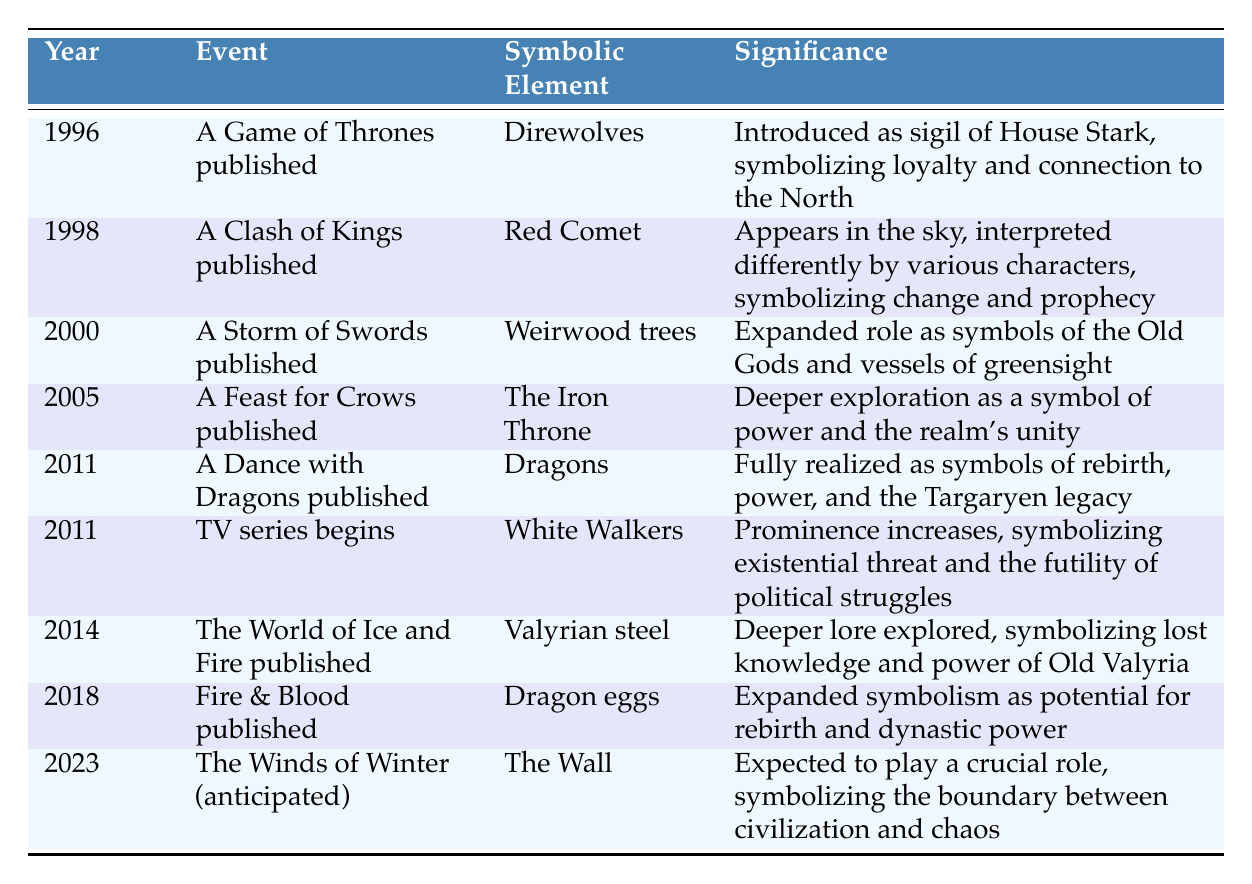What year was A Game of Thrones published? The table lists events from a timeline, and directly shows that A Game of Thrones was published in the year 1996.
Answer: 1996 What is the significance of the Red Comet in A Clash of Kings? According to the table, the Red Comet appears in the sky and is interpreted differently by various characters; it symbolizes change and prophecy.
Answer: Change and prophecy How many symbolic elements were introduced in 2011? By examining the table, we note that there are two entries in the year 2011: Dragons from A Dance with Dragons and White Walkers from the start of the TV series, leading to a total of two symbolic elements introduced that year.
Answer: 2 Is the Iron Throne a symbol of unity according to the table? The table specifies that the Iron Throne is explored as a symbol of power and the realm's unity, confirming that it is indeed seen as a symbol of unity.
Answer: Yes Which symbolic element reflects the theme of rebirth and power most significantly? From the table, both Dragons and Dragon eggs are associated with symbols of rebirth and power. However, Dragons are described as fully realized symbols of rebirth, while Dragon eggs are expanded upon in terms of potential; thus, Dragons are more prominently associated with the theme.
Answer: Dragons What is the progression of significant symbolic elements from the start of the series to the anticipated Winds of Winter? By analyzing the events chronologically, we see a gradual introduction and expansion of symbolic elements: starting with Direwolves representing loyalty, followed by various symbols like the Iron Throne, and finally leading to The Wall symbolizing civilization's boundary. This shows an evolution of symbolism that reflects the series' themes.
Answer: Evolution of symbolism Are Valyrian steel and the White Walkers mentioned in the same publication year? The table shows that Valyrian steel was discussed in the 2014 publication of The World of Ice and Fire, while White Walkers appeared in the 2011 debut of the TV series, indicating they are not mentioned in the same year.
Answer: No How does the symbolism of The Wall compare to that of the Iron Throne? While the Iron Throne symbolizes power and unity of the realm, The Wall is expected to symbolize the boundary between civilization and chaos, thus contrasting the themes of governance and survival in the series' narrative. This comparative analysis highlights a shift from political power to existential themes.
Answer: Contrasting themes 